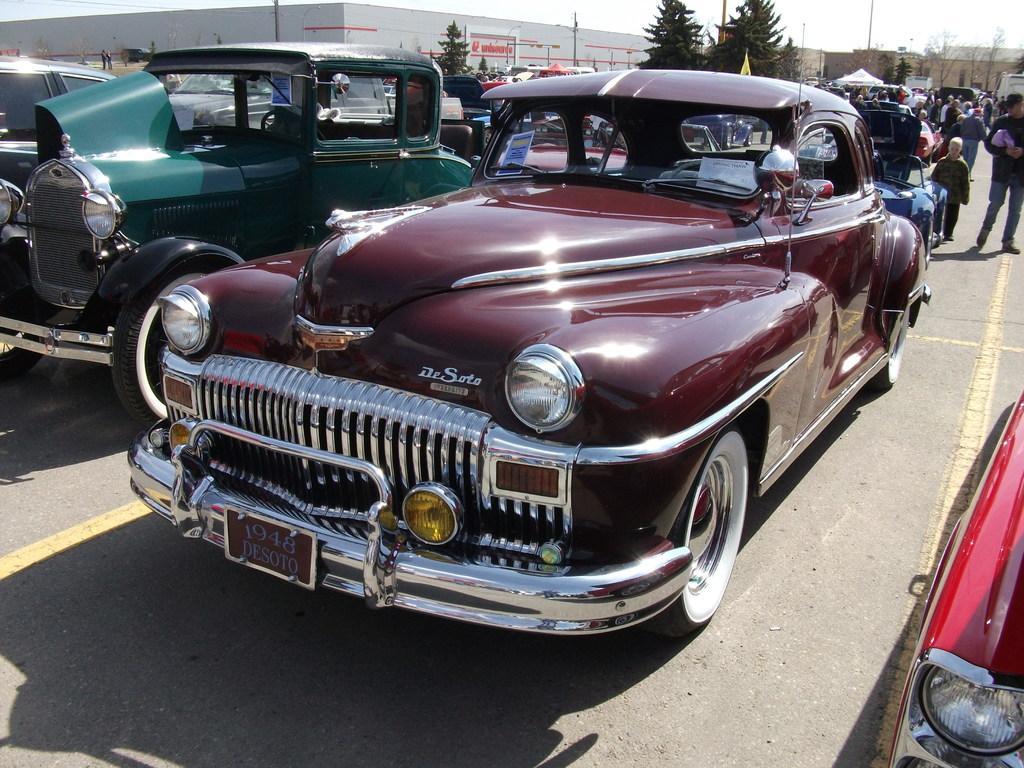Please provide a concise description of this image. There are vehicles in different colors and persons on the road, on which there are yellow color lines. In the background, there are trees, buildings and there is sky. 